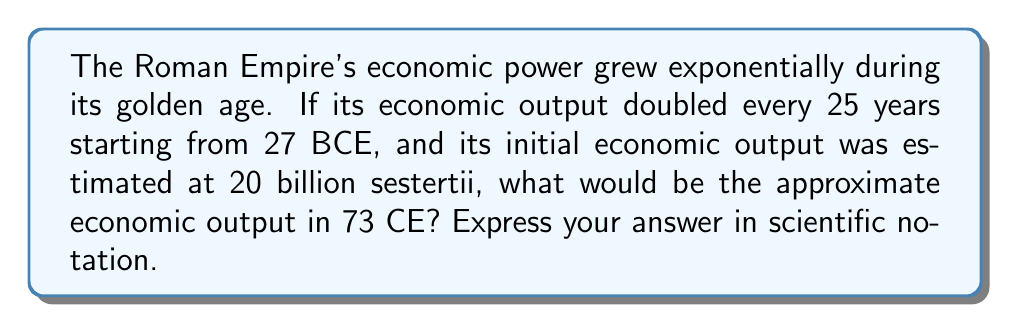Show me your answer to this math problem. To solve this problem, we need to follow these steps:

1. Calculate the number of 25-year periods between 27 BCE and 73 CE:
   27 BCE to 73 CE = 100 years
   Number of periods = 100 ÷ 25 = 4

2. Use the exponential growth formula:
   $A = P \cdot 2^n$
   Where:
   $A$ = Final amount
   $P$ = Initial amount (20 billion sestertii)
   $n$ = Number of periods (4)

3. Plug in the values:
   $A = 20 \cdot 10^9 \cdot 2^4$

4. Calculate:
   $A = 20 \cdot 10^9 \cdot 16$
   $A = 320 \cdot 10^9$

5. Convert to scientific notation:
   $A = 3.2 \cdot 10^{11}$ sestertii

This estimation shows how exponential growth can lead to significant increases in economic power over time, which is crucial for understanding the rise and fall of historical empires.
Answer: $3.2 \cdot 10^{11}$ sestertii 